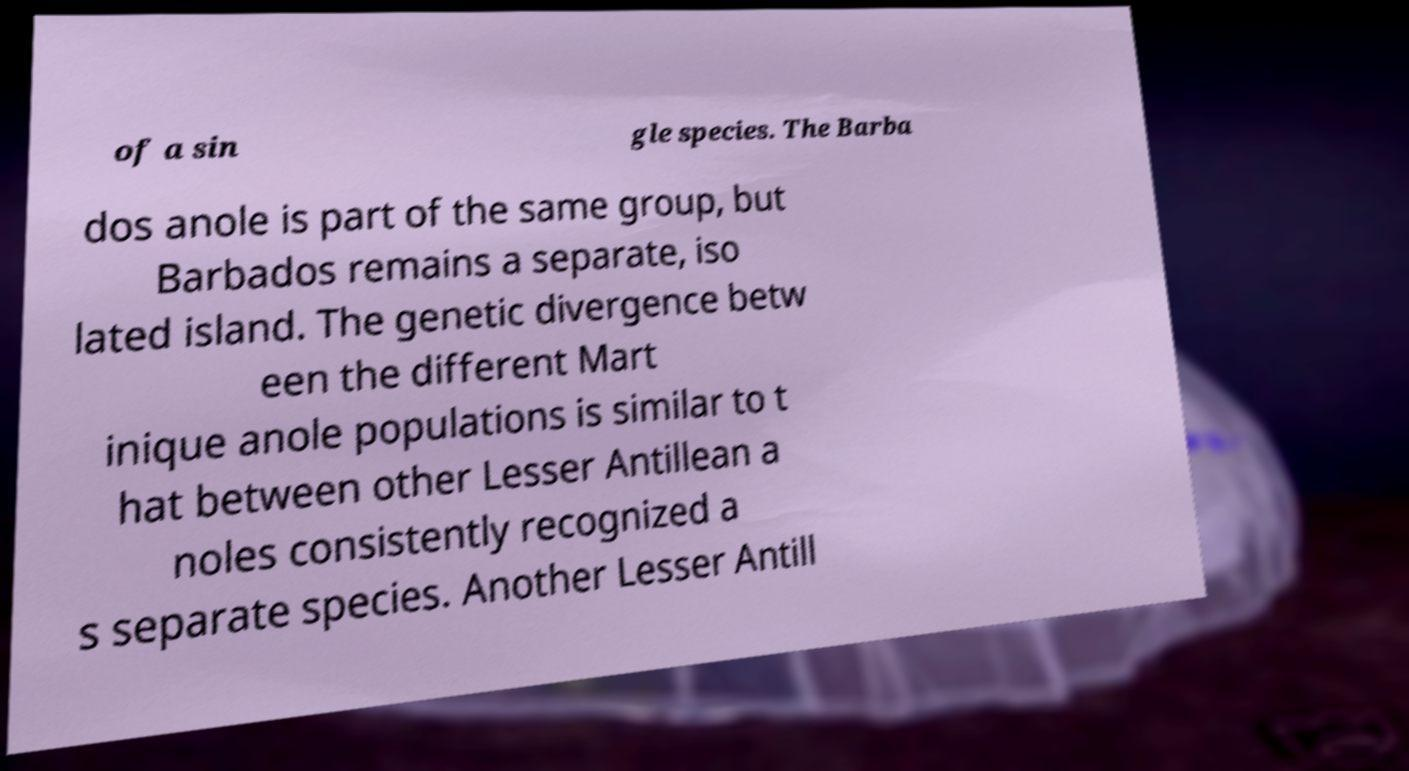Could you assist in decoding the text presented in this image and type it out clearly? of a sin gle species. The Barba dos anole is part of the same group, but Barbados remains a separate, iso lated island. The genetic divergence betw een the different Mart inique anole populations is similar to t hat between other Lesser Antillean a noles consistently recognized a s separate species. Another Lesser Antill 